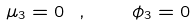Convert formula to latex. <formula><loc_0><loc_0><loc_500><loc_500>\mu _ { 3 } = 0 \ , \quad \phi _ { 3 } = 0</formula> 